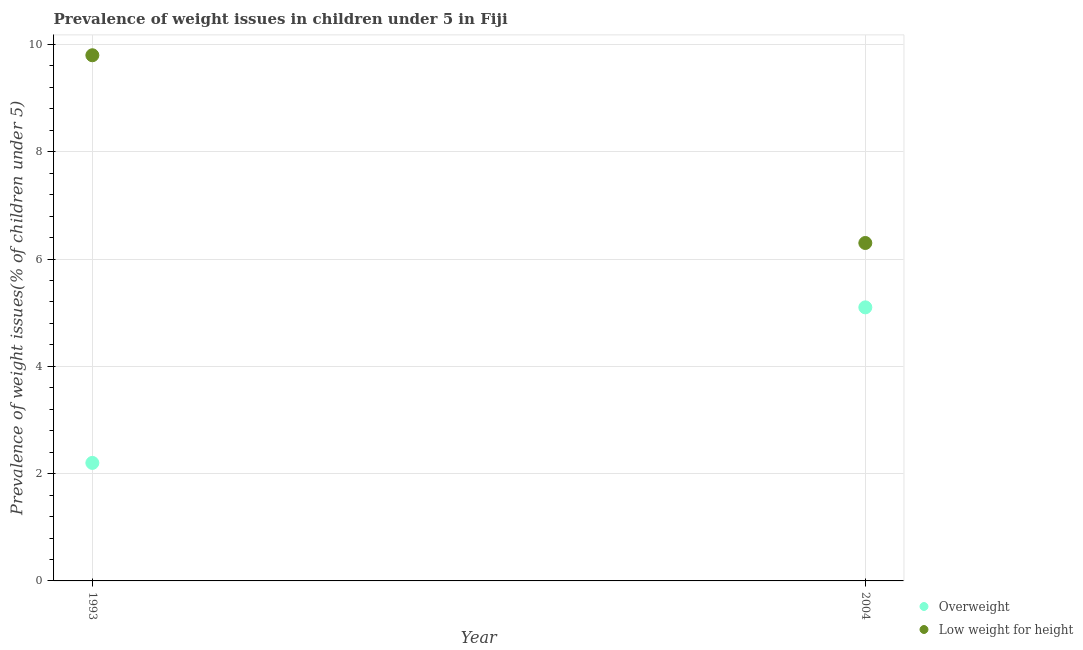How many different coloured dotlines are there?
Ensure brevity in your answer.  2. Is the number of dotlines equal to the number of legend labels?
Your answer should be very brief. Yes. What is the percentage of underweight children in 1993?
Provide a succinct answer. 9.8. Across all years, what is the maximum percentage of underweight children?
Make the answer very short. 9.8. Across all years, what is the minimum percentage of underweight children?
Make the answer very short. 6.3. In which year was the percentage of overweight children maximum?
Ensure brevity in your answer.  2004. What is the total percentage of overweight children in the graph?
Your answer should be very brief. 7.3. What is the difference between the percentage of underweight children in 1993 and that in 2004?
Offer a terse response. 3.5. What is the difference between the percentage of overweight children in 1993 and the percentage of underweight children in 2004?
Your answer should be compact. -4.1. What is the average percentage of underweight children per year?
Provide a short and direct response. 8.05. In the year 1993, what is the difference between the percentage of underweight children and percentage of overweight children?
Offer a terse response. 7.6. What is the ratio of the percentage of underweight children in 1993 to that in 2004?
Offer a very short reply. 1.56. In how many years, is the percentage of underweight children greater than the average percentage of underweight children taken over all years?
Offer a very short reply. 1. Is the percentage of underweight children strictly greater than the percentage of overweight children over the years?
Your answer should be very brief. Yes. Is the percentage of underweight children strictly less than the percentage of overweight children over the years?
Ensure brevity in your answer.  No. How many dotlines are there?
Your response must be concise. 2. Are the values on the major ticks of Y-axis written in scientific E-notation?
Offer a terse response. No. Does the graph contain grids?
Offer a very short reply. Yes. Where does the legend appear in the graph?
Your answer should be compact. Bottom right. How are the legend labels stacked?
Offer a terse response. Vertical. What is the title of the graph?
Offer a very short reply. Prevalence of weight issues in children under 5 in Fiji. Does "State government" appear as one of the legend labels in the graph?
Make the answer very short. No. What is the label or title of the X-axis?
Provide a short and direct response. Year. What is the label or title of the Y-axis?
Give a very brief answer. Prevalence of weight issues(% of children under 5). What is the Prevalence of weight issues(% of children under 5) of Overweight in 1993?
Ensure brevity in your answer.  2.2. What is the Prevalence of weight issues(% of children under 5) in Low weight for height in 1993?
Ensure brevity in your answer.  9.8. What is the Prevalence of weight issues(% of children under 5) in Overweight in 2004?
Give a very brief answer. 5.1. What is the Prevalence of weight issues(% of children under 5) in Low weight for height in 2004?
Provide a succinct answer. 6.3. Across all years, what is the maximum Prevalence of weight issues(% of children under 5) of Overweight?
Provide a short and direct response. 5.1. Across all years, what is the maximum Prevalence of weight issues(% of children under 5) of Low weight for height?
Provide a short and direct response. 9.8. Across all years, what is the minimum Prevalence of weight issues(% of children under 5) in Overweight?
Your response must be concise. 2.2. Across all years, what is the minimum Prevalence of weight issues(% of children under 5) in Low weight for height?
Your answer should be very brief. 6.3. What is the difference between the Prevalence of weight issues(% of children under 5) of Low weight for height in 1993 and that in 2004?
Offer a terse response. 3.5. What is the difference between the Prevalence of weight issues(% of children under 5) in Overweight in 1993 and the Prevalence of weight issues(% of children under 5) in Low weight for height in 2004?
Make the answer very short. -4.1. What is the average Prevalence of weight issues(% of children under 5) of Overweight per year?
Ensure brevity in your answer.  3.65. What is the average Prevalence of weight issues(% of children under 5) of Low weight for height per year?
Ensure brevity in your answer.  8.05. In the year 2004, what is the difference between the Prevalence of weight issues(% of children under 5) of Overweight and Prevalence of weight issues(% of children under 5) of Low weight for height?
Ensure brevity in your answer.  -1.2. What is the ratio of the Prevalence of weight issues(% of children under 5) in Overweight in 1993 to that in 2004?
Offer a terse response. 0.43. What is the ratio of the Prevalence of weight issues(% of children under 5) of Low weight for height in 1993 to that in 2004?
Keep it short and to the point. 1.56. 